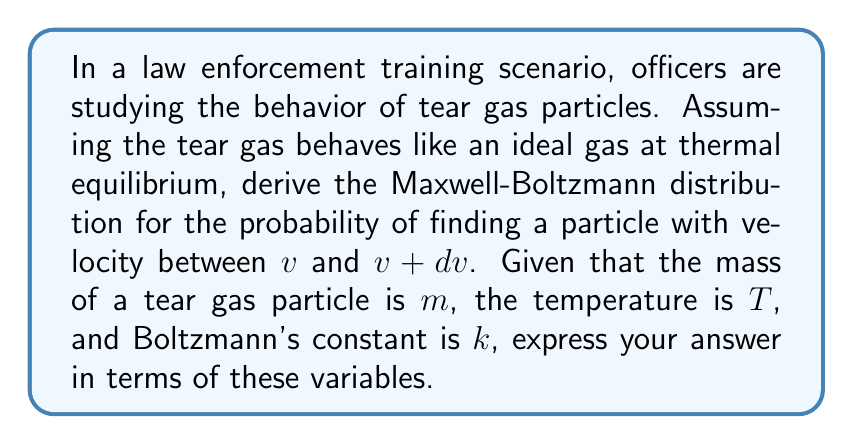Solve this math problem. 1. Start with the general form of the Maxwell-Boltzmann distribution:
   $$f(v) = A \exp(-\frac{mv^2}{2kT})$$
   where $A$ is a normalization constant.

2. To find $A$, use the normalization condition:
   $$\int_0^\infty 4\pi v^2 f(v) dv = 1$$

3. Substitute the general form into the normalization condition:
   $$4\pi A \int_0^\infty v^2 \exp(-\frac{mv^2}{2kT}) dv = 1$$

4. Solve the integral using the substitution $u = \frac{mv^2}{2kT}$:
   $$4\pi A (\frac{2kT}{m})^{3/2} \int_0^\infty u^{1/2} e^{-u} du = 1$$
   The integral evaluates to $\frac{\sqrt{\pi}}{2}$.

5. Solve for $A$:
   $$A = (\frac{m}{2\pi kT})^{3/2}$$

6. Substitute $A$ back into the general form:
   $$f(v) = (\frac{m}{2\pi kT})^{3/2} \exp(-\frac{mv^2}{2kT})$$

7. The probability of finding a particle with velocity between $v$ and $v + dv$ is:
   $$P(v)dv = 4\pi v^2 f(v) dv$$

8. Substitute $f(v)$ into this expression:
   $$P(v)dv = 4\pi v^2 (\frac{m}{2\pi kT})^{3/2} \exp(-\frac{mv^2}{2kT}) dv$$
Answer: $$P(v)dv = 4\pi (\frac{m}{2\pi kT})^{3/2} v^2 \exp(-\frac{mv^2}{2kT}) dv$$ 